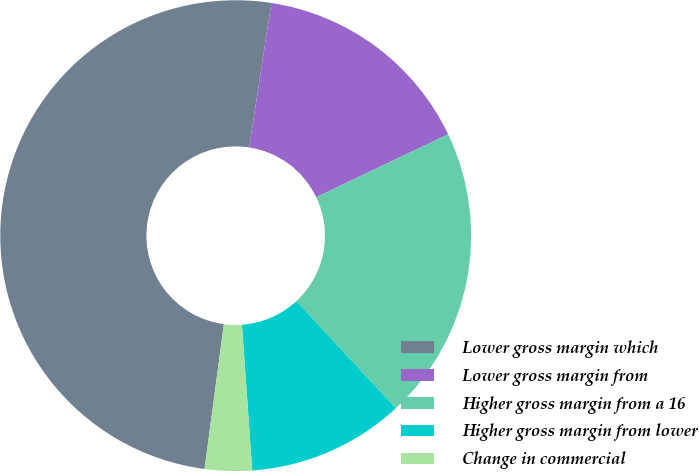Convert chart. <chart><loc_0><loc_0><loc_500><loc_500><pie_chart><fcel>Lower gross margin which<fcel>Lower gross margin from<fcel>Higher gross margin from a 16<fcel>Higher gross margin from lower<fcel>Change in commercial<nl><fcel>50.31%<fcel>15.49%<fcel>20.19%<fcel>10.78%<fcel>3.23%<nl></chart> 